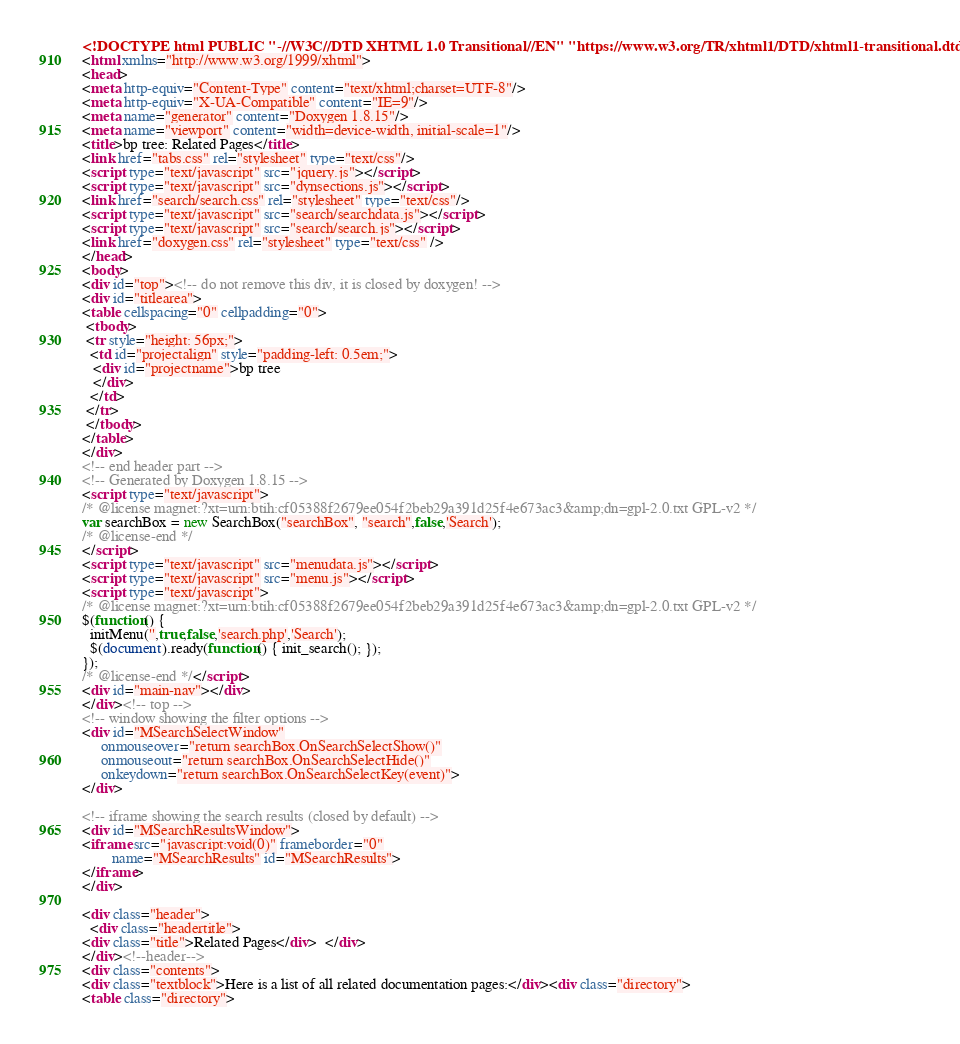<code> <loc_0><loc_0><loc_500><loc_500><_HTML_><!DOCTYPE html PUBLIC "-//W3C//DTD XHTML 1.0 Transitional//EN" "https://www.w3.org/TR/xhtml1/DTD/xhtml1-transitional.dtd">
<html xmlns="http://www.w3.org/1999/xhtml">
<head>
<meta http-equiv="Content-Type" content="text/xhtml;charset=UTF-8"/>
<meta http-equiv="X-UA-Compatible" content="IE=9"/>
<meta name="generator" content="Doxygen 1.8.15"/>
<meta name="viewport" content="width=device-width, initial-scale=1"/>
<title>bp tree: Related Pages</title>
<link href="tabs.css" rel="stylesheet" type="text/css"/>
<script type="text/javascript" src="jquery.js"></script>
<script type="text/javascript" src="dynsections.js"></script>
<link href="search/search.css" rel="stylesheet" type="text/css"/>
<script type="text/javascript" src="search/searchdata.js"></script>
<script type="text/javascript" src="search/search.js"></script>
<link href="doxygen.css" rel="stylesheet" type="text/css" />
</head>
<body>
<div id="top"><!-- do not remove this div, it is closed by doxygen! -->
<div id="titlearea">
<table cellspacing="0" cellpadding="0">
 <tbody>
 <tr style="height: 56px;">
  <td id="projectalign" style="padding-left: 0.5em;">
   <div id="projectname">bp tree
   </div>
  </td>
 </tr>
 </tbody>
</table>
</div>
<!-- end header part -->
<!-- Generated by Doxygen 1.8.15 -->
<script type="text/javascript">
/* @license magnet:?xt=urn:btih:cf05388f2679ee054f2beb29a391d25f4e673ac3&amp;dn=gpl-2.0.txt GPL-v2 */
var searchBox = new SearchBox("searchBox", "search",false,'Search');
/* @license-end */
</script>
<script type="text/javascript" src="menudata.js"></script>
<script type="text/javascript" src="menu.js"></script>
<script type="text/javascript">
/* @license magnet:?xt=urn:btih:cf05388f2679ee054f2beb29a391d25f4e673ac3&amp;dn=gpl-2.0.txt GPL-v2 */
$(function() {
  initMenu('',true,false,'search.php','Search');
  $(document).ready(function() { init_search(); });
});
/* @license-end */</script>
<div id="main-nav"></div>
</div><!-- top -->
<!-- window showing the filter options -->
<div id="MSearchSelectWindow"
     onmouseover="return searchBox.OnSearchSelectShow()"
     onmouseout="return searchBox.OnSearchSelectHide()"
     onkeydown="return searchBox.OnSearchSelectKey(event)">
</div>

<!-- iframe showing the search results (closed by default) -->
<div id="MSearchResultsWindow">
<iframe src="javascript:void(0)" frameborder="0" 
        name="MSearchResults" id="MSearchResults">
</iframe>
</div>

<div class="header">
  <div class="headertitle">
<div class="title">Related Pages</div>  </div>
</div><!--header-->
<div class="contents">
<div class="textblock">Here is a list of all related documentation pages:</div><div class="directory">
<table class="directory"></code> 